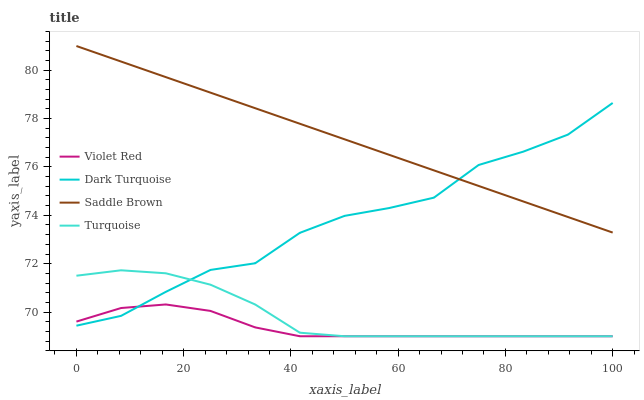Does Turquoise have the minimum area under the curve?
Answer yes or no. No. Does Turquoise have the maximum area under the curve?
Answer yes or no. No. Is Violet Red the smoothest?
Answer yes or no. No. Is Violet Red the roughest?
Answer yes or no. No. Does Saddle Brown have the lowest value?
Answer yes or no. No. Does Turquoise have the highest value?
Answer yes or no. No. Is Violet Red less than Saddle Brown?
Answer yes or no. Yes. Is Saddle Brown greater than Turquoise?
Answer yes or no. Yes. Does Violet Red intersect Saddle Brown?
Answer yes or no. No. 